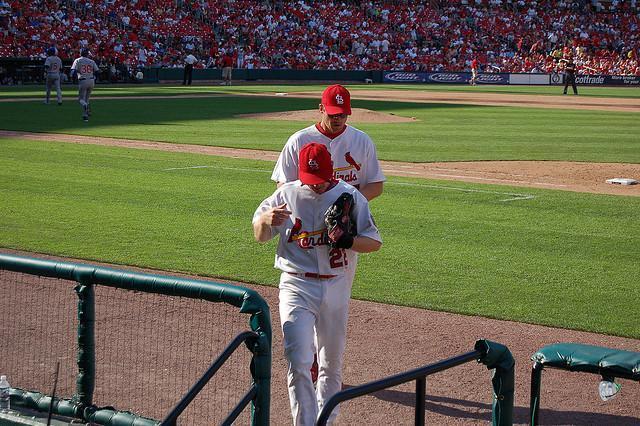How many people can be seen?
Give a very brief answer. 2. 